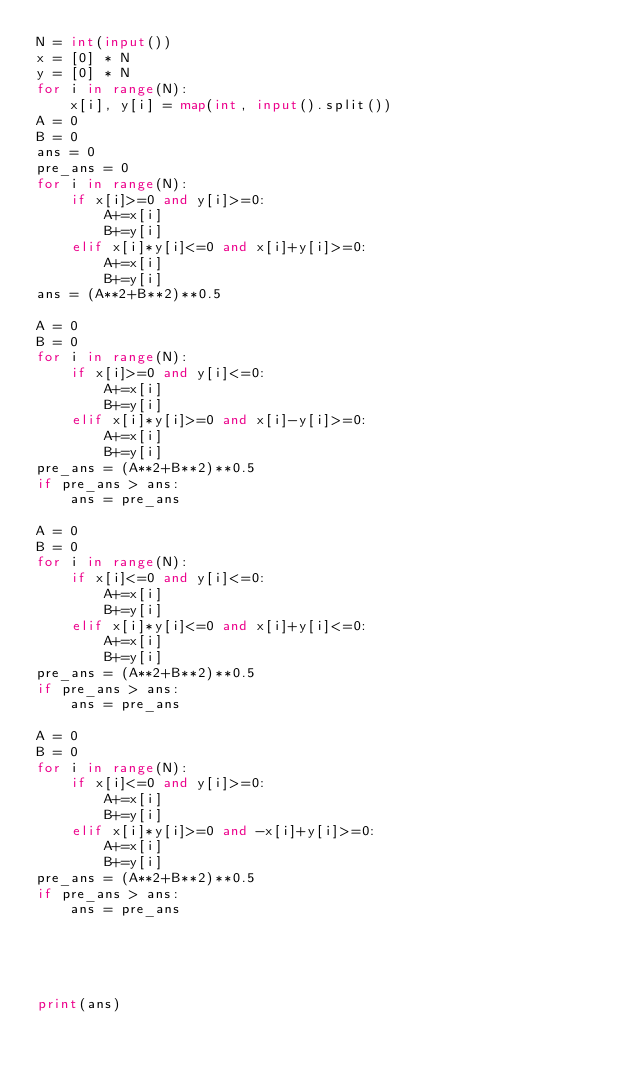Convert code to text. <code><loc_0><loc_0><loc_500><loc_500><_Python_>N = int(input())
x = [0] * N
y = [0] * N
for i in range(N):
    x[i], y[i] = map(int, input().split())
A = 0
B = 0
ans = 0
pre_ans = 0
for i in range(N):
    if x[i]>=0 and y[i]>=0:
        A+=x[i]
        B+=y[i]
    elif x[i]*y[i]<=0 and x[i]+y[i]>=0:
        A+=x[i]
        B+=y[i]
ans = (A**2+B**2)**0.5

A = 0
B = 0
for i in range(N):
    if x[i]>=0 and y[i]<=0:
        A+=x[i]
        B+=y[i]
    elif x[i]*y[i]>=0 and x[i]-y[i]>=0:
        A+=x[i]
        B+=y[i]
pre_ans = (A**2+B**2)**0.5
if pre_ans > ans:
    ans = pre_ans

A = 0
B = 0
for i in range(N):
    if x[i]<=0 and y[i]<=0:
        A+=x[i]
        B+=y[i]
    elif x[i]*y[i]<=0 and x[i]+y[i]<=0:
        A+=x[i]
        B+=y[i]
pre_ans = (A**2+B**2)**0.5
if pre_ans > ans:
    ans = pre_ans

A = 0
B = 0
for i in range(N):
    if x[i]<=0 and y[i]>=0:
        A+=x[i]
        B+=y[i]
    elif x[i]*y[i]>=0 and -x[i]+y[i]>=0:
        A+=x[i]
        B+=y[i]
pre_ans = (A**2+B**2)**0.5
if pre_ans > ans:
    ans = pre_ans





print(ans)
</code> 